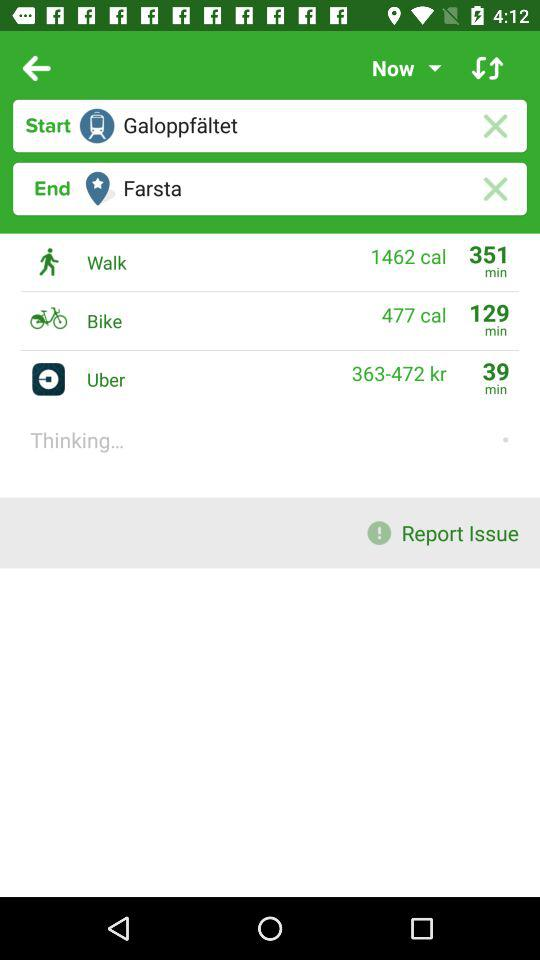How many calories are burned by walking? The total calories burned by walking is 1462. 